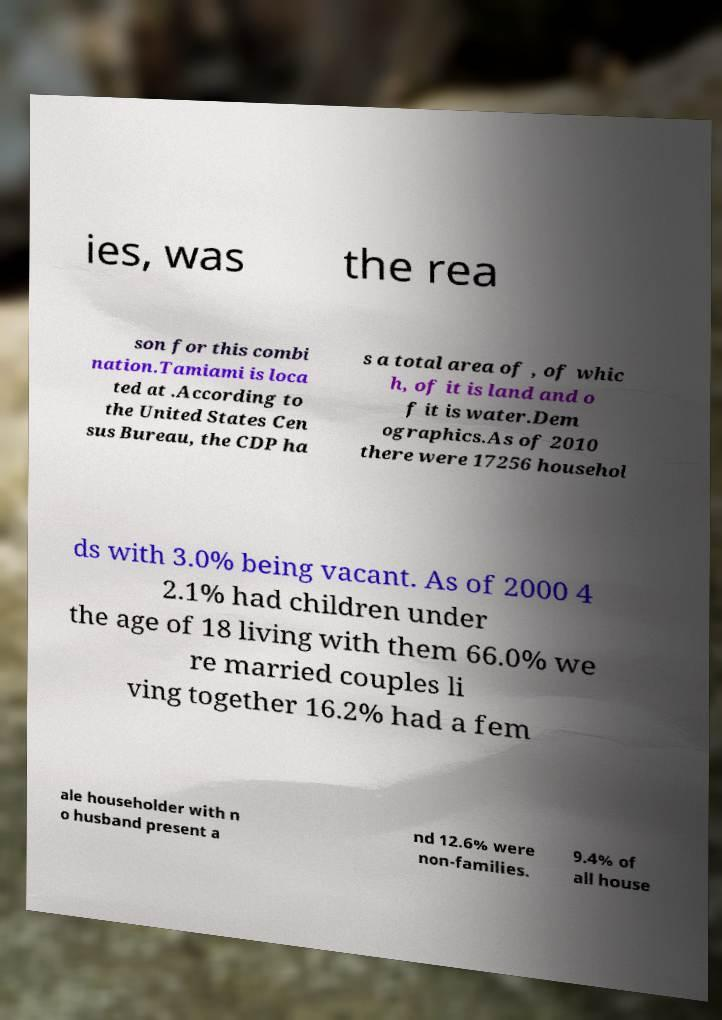I need the written content from this picture converted into text. Can you do that? ies, was the rea son for this combi nation.Tamiami is loca ted at .According to the United States Cen sus Bureau, the CDP ha s a total area of , of whic h, of it is land and o f it is water.Dem ographics.As of 2010 there were 17256 househol ds with 3.0% being vacant. As of 2000 4 2.1% had children under the age of 18 living with them 66.0% we re married couples li ving together 16.2% had a fem ale householder with n o husband present a nd 12.6% were non-families. 9.4% of all house 